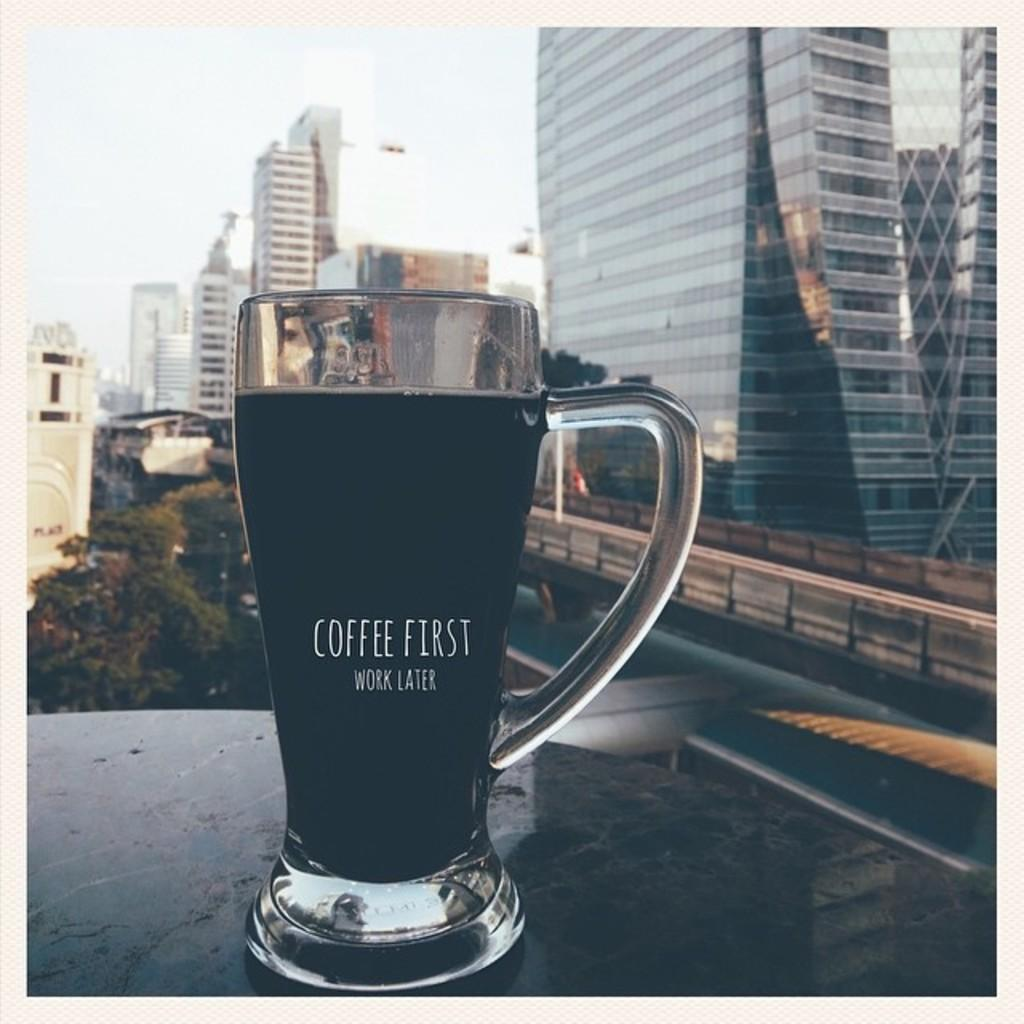<image>
Describe the image concisely. A mug type glass with coffee first work later written on it. 